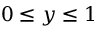Convert formula to latex. <formula><loc_0><loc_0><loc_500><loc_500>0 \leq y \leq 1</formula> 